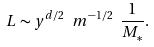Convert formula to latex. <formula><loc_0><loc_0><loc_500><loc_500>L \sim y ^ { d / 2 } \ m ^ { - 1 / 2 } \ \frac { 1 } { M _ { \ast } } .</formula> 